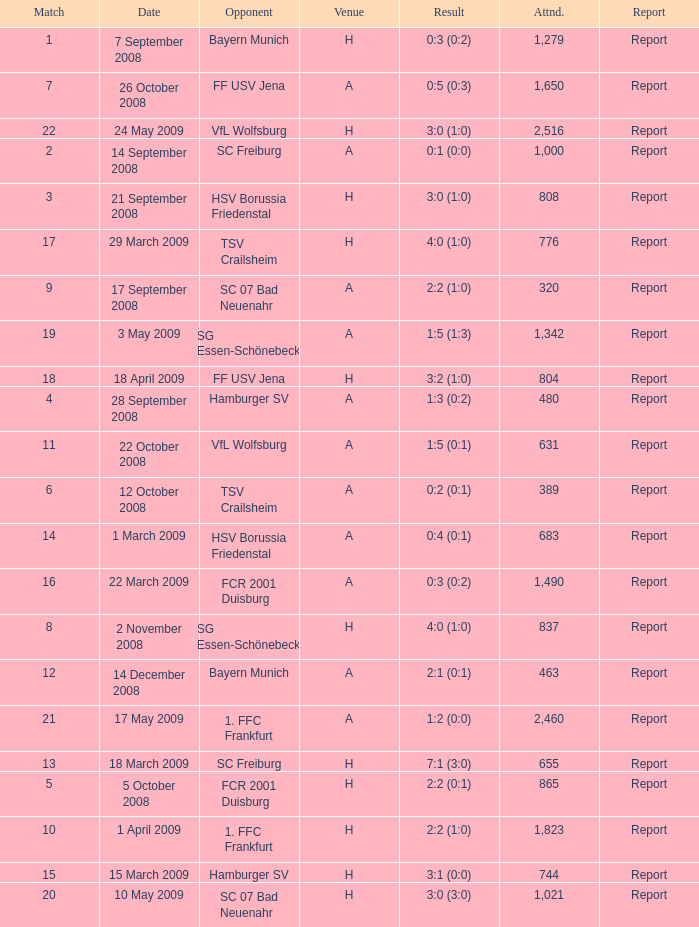What is the match number that had a result of 0:5 (0:3)? 1.0. 